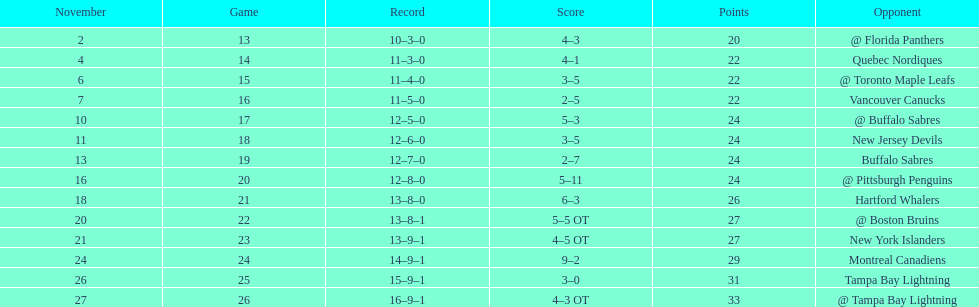The 1993-1994 flyers missed the playoffs again. how many consecutive seasons up until 93-94 did the flyers miss the playoffs? 5. 